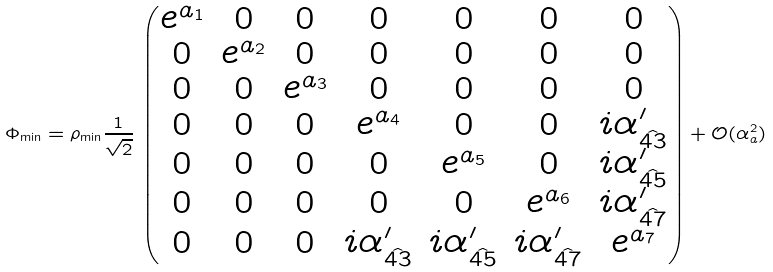<formula> <loc_0><loc_0><loc_500><loc_500>\Phi _ { \min } = \rho _ { \min } \frac { 1 } { \sqrt { 2 } } \, \begin{pmatrix} e ^ { a _ { 1 } } & 0 & 0 & 0 & 0 & 0 & 0 \\ 0 & e ^ { a _ { 2 } } & 0 & 0 & 0 & 0 & 0 \\ 0 & 0 & e ^ { a _ { 3 } } & 0 & 0 & 0 & 0 \\ 0 & 0 & 0 & e ^ { a _ { 4 } } & 0 & 0 & i \alpha _ { \hat { 4 3 } } ^ { \prime } \\ 0 & 0 & 0 & 0 & e ^ { a _ { 5 } } & 0 & i \alpha _ { \hat { 4 5 } } ^ { \prime } \\ 0 & 0 & 0 & 0 & 0 & e ^ { a _ { 6 } } & i \alpha _ { \hat { 4 7 } } ^ { \prime } \\ 0 & 0 & 0 & i \alpha _ { \hat { 4 3 } } ^ { \prime } & i \alpha _ { \hat { 4 5 } } ^ { \prime } & i \alpha _ { \hat { 4 7 } } ^ { \prime } & e ^ { a _ { 7 } } \end{pmatrix} + \mathcal { O } ( \alpha _ { a } ^ { 2 } )</formula> 